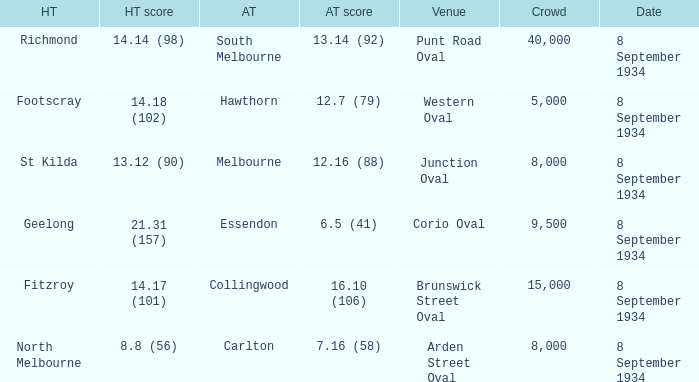When the Venue was Punt Road Oval, who was the Home Team? Richmond. 